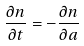<formula> <loc_0><loc_0><loc_500><loc_500>\frac { \partial n } { \partial t } = - \frac { \partial n } { \partial a }</formula> 